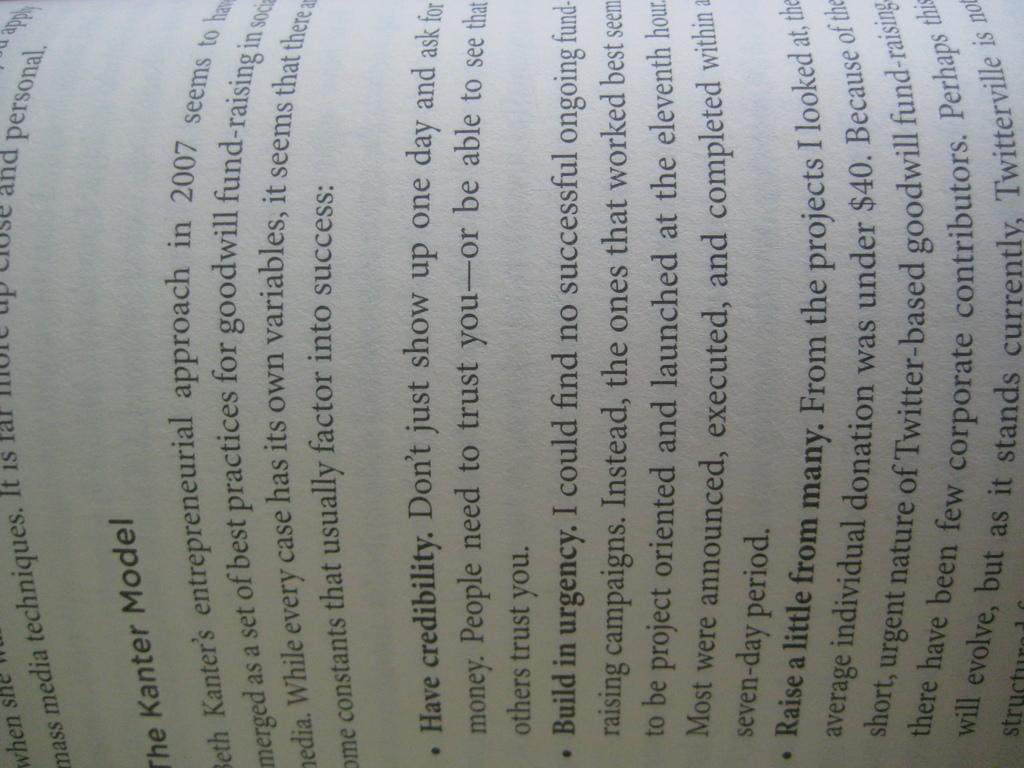Provide a one-sentence caption for the provided image. A book opened to the headline of The Kanter Model. 